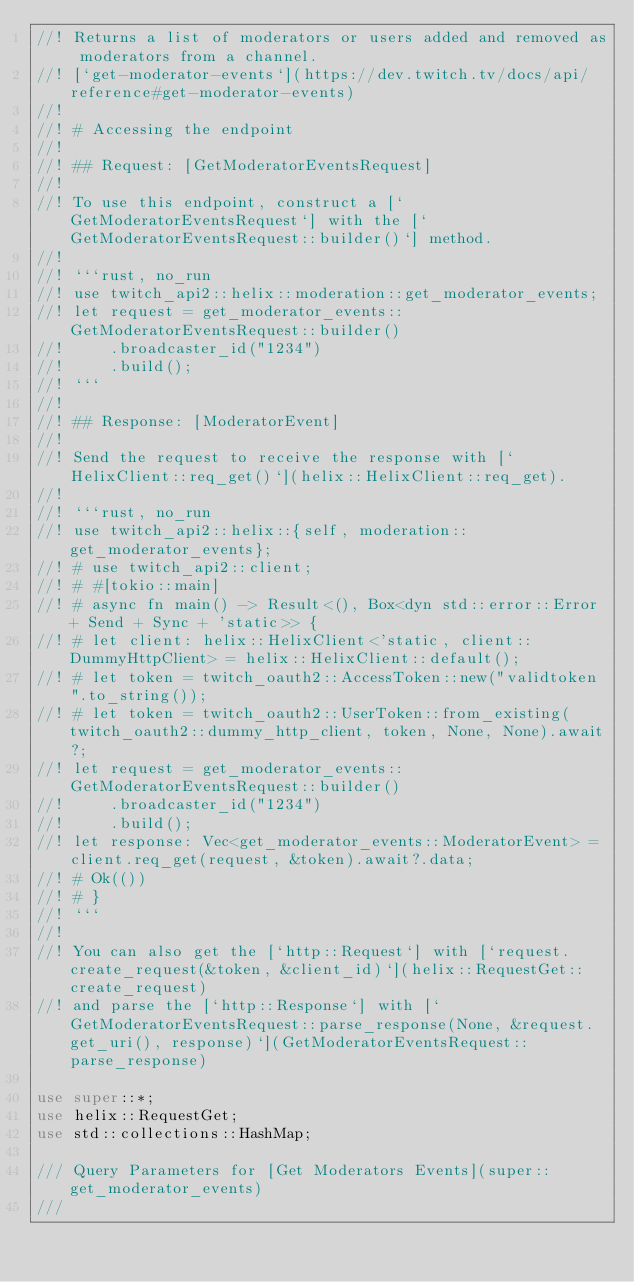<code> <loc_0><loc_0><loc_500><loc_500><_Rust_>//! Returns a list of moderators or users added and removed as moderators from a channel.
//! [`get-moderator-events`](https://dev.twitch.tv/docs/api/reference#get-moderator-events)
//!
//! # Accessing the endpoint
//!
//! ## Request: [GetModeratorEventsRequest]
//!
//! To use this endpoint, construct a [`GetModeratorEventsRequest`] with the [`GetModeratorEventsRequest::builder()`] method.
//!
//! ```rust, no_run
//! use twitch_api2::helix::moderation::get_moderator_events;
//! let request = get_moderator_events::GetModeratorEventsRequest::builder()
//!     .broadcaster_id("1234")
//!     .build();
//! ```
//!
//! ## Response: [ModeratorEvent]
//!
//! Send the request to receive the response with [`HelixClient::req_get()`](helix::HelixClient::req_get).
//!
//! ```rust, no_run
//! use twitch_api2::helix::{self, moderation::get_moderator_events};
//! # use twitch_api2::client;
//! # #[tokio::main]
//! # async fn main() -> Result<(), Box<dyn std::error::Error + Send + Sync + 'static>> {
//! # let client: helix::HelixClient<'static, client::DummyHttpClient> = helix::HelixClient::default();
//! # let token = twitch_oauth2::AccessToken::new("validtoken".to_string());
//! # let token = twitch_oauth2::UserToken::from_existing(twitch_oauth2::dummy_http_client, token, None, None).await?;
//! let request = get_moderator_events::GetModeratorEventsRequest::builder()
//!     .broadcaster_id("1234")
//!     .build();
//! let response: Vec<get_moderator_events::ModeratorEvent> = client.req_get(request, &token).await?.data;
//! # Ok(())
//! # }
//! ```
//!
//! You can also get the [`http::Request`] with [`request.create_request(&token, &client_id)`](helix::RequestGet::create_request)
//! and parse the [`http::Response`] with [`GetModeratorEventsRequest::parse_response(None, &request.get_uri(), response)`](GetModeratorEventsRequest::parse_response)

use super::*;
use helix::RequestGet;
use std::collections::HashMap;

/// Query Parameters for [Get Moderators Events](super::get_moderator_events)
///</code> 